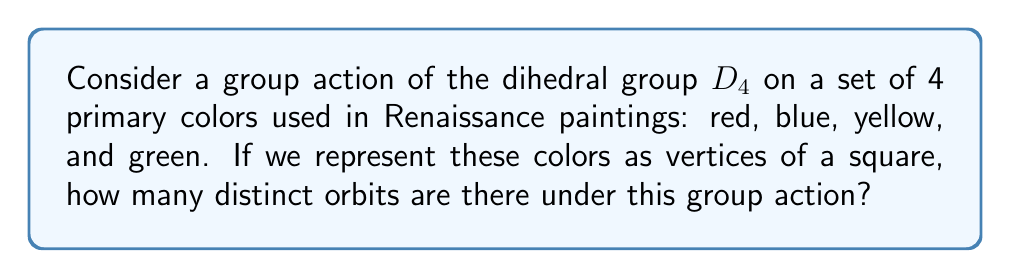Give your solution to this math problem. Let's approach this step-by-step:

1) First, recall that $D_4$ is the symmetry group of a square, consisting of 8 elements: 4 rotations and 4 reflections.

2) The colors (red, blue, yellow, green) can be thought of as vertices of a square, labeled clockwise.

3) To find the number of orbits, we can use Burnside's lemma:

   $$|X/G| = \frac{1}{|G|} \sum_{g \in G} |X^g|$$

   Where $|X/G|$ is the number of orbits, $|G|$ is the order of the group, and $|X^g|$ is the number of elements fixed by each group element $g$.

4) Let's count the fixed points for each element of $D_4$:
   - Identity: fixes all 4 colors
   - 90° rotation: fixes 0 colors
   - 180° rotation: fixes 0 colors
   - 270° rotation: fixes 0 colors
   - Reflection about vertical axis: fixes 2 colors
   - Reflection about horizontal axis: fixes 2 colors
   - Reflection about diagonal: fixes 2 colors
   - Reflection about other diagonal: fixes 2 colors

5) Applying Burnside's lemma:

   $$|X/G| = \frac{1}{8}(4 + 0 + 0 + 0 + 2 + 2 + 2 + 2) = \frac{1}{8}(12) = \frac{3}{2}$$

6) Since the number of orbits must be a whole number, we round up to 2.
Answer: 2 orbits 